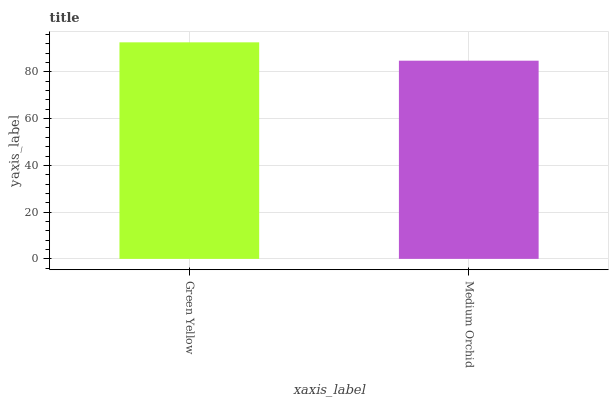Is Medium Orchid the maximum?
Answer yes or no. No. Is Green Yellow greater than Medium Orchid?
Answer yes or no. Yes. Is Medium Orchid less than Green Yellow?
Answer yes or no. Yes. Is Medium Orchid greater than Green Yellow?
Answer yes or no. No. Is Green Yellow less than Medium Orchid?
Answer yes or no. No. Is Green Yellow the high median?
Answer yes or no. Yes. Is Medium Orchid the low median?
Answer yes or no. Yes. Is Medium Orchid the high median?
Answer yes or no. No. Is Green Yellow the low median?
Answer yes or no. No. 